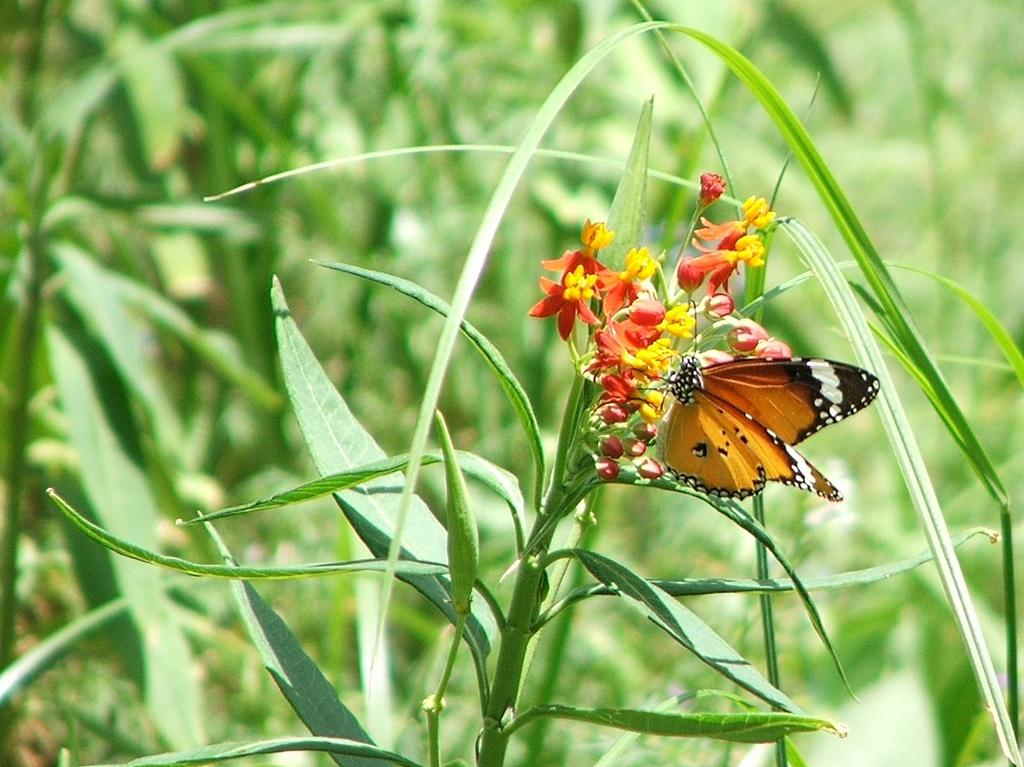What type of animal can be seen in the image? There is a butterfly in the image. What other living organisms are present in the image? There are flowers in the image. What colors are the flowers? The flowers are red and yellow in color. What else can be seen in the image besides the butterfly and flowers? There are leaves in the image. How would you describe the background of the image? The background of the image is blurred. What type of flag is visible in the image? There is no flag present in the image. Can you see any ants in the image? There are no ants visible in the image. 